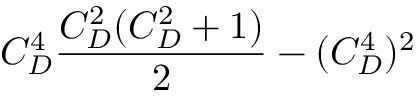Convert formula to latex. <formula><loc_0><loc_0><loc_500><loc_500>C _ { D } ^ { 4 } { \frac { C _ { D } ^ { 2 } ( C _ { D } ^ { 2 } + 1 ) } { 2 } } - ( C _ { D } ^ { 4 } ) ^ { 2 }</formula> 